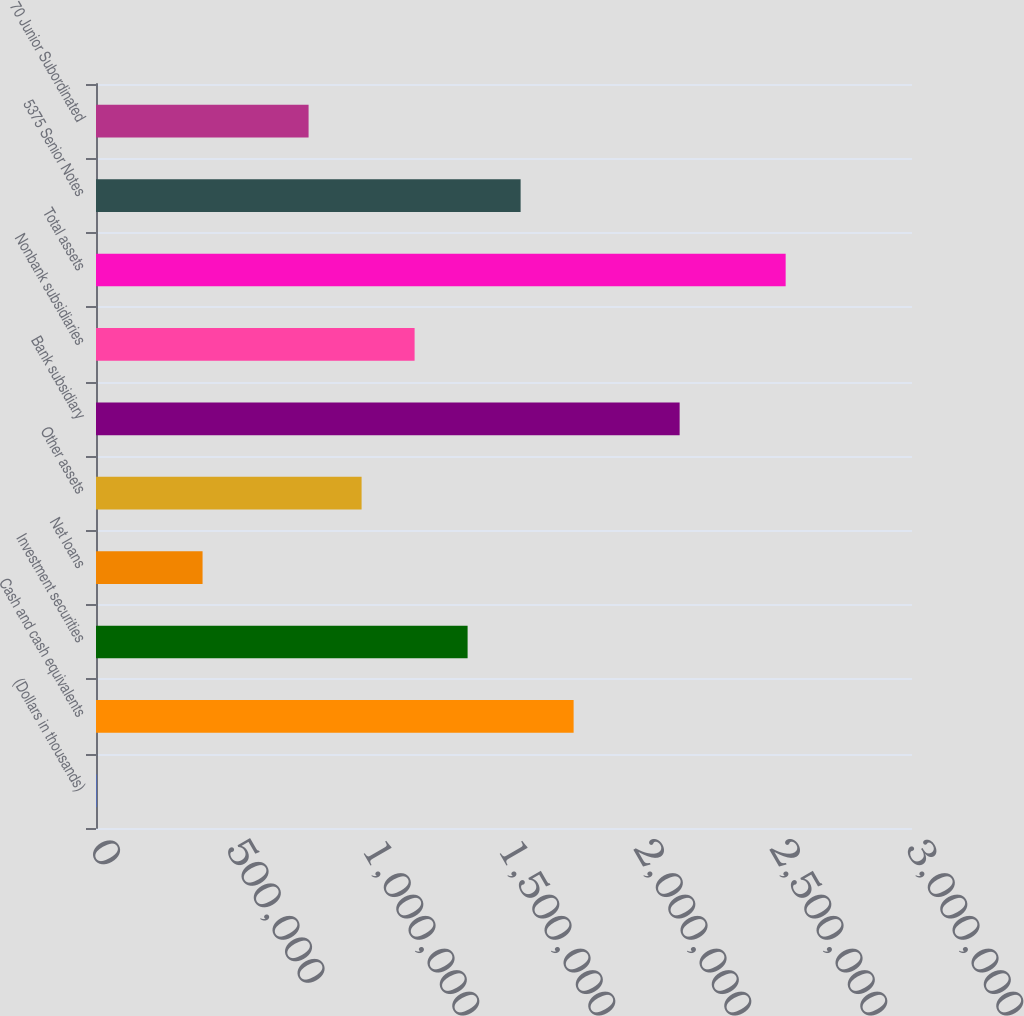Convert chart to OTSL. <chart><loc_0><loc_0><loc_500><loc_500><bar_chart><fcel>(Dollars in thousands)<fcel>Cash and cash equivalents<fcel>Investment securities<fcel>Net loans<fcel>Other assets<fcel>Bank subsidiary<fcel>Nonbank subsidiaries<fcel>Total assets<fcel>5375 Senior Notes<fcel>70 Junior Subordinated<nl><fcel>2010<fcel>1.75595e+06<fcel>1.36618e+06<fcel>391774<fcel>976420<fcel>2.14571e+06<fcel>1.1713e+06<fcel>2.53548e+06<fcel>1.56107e+06<fcel>781538<nl></chart> 